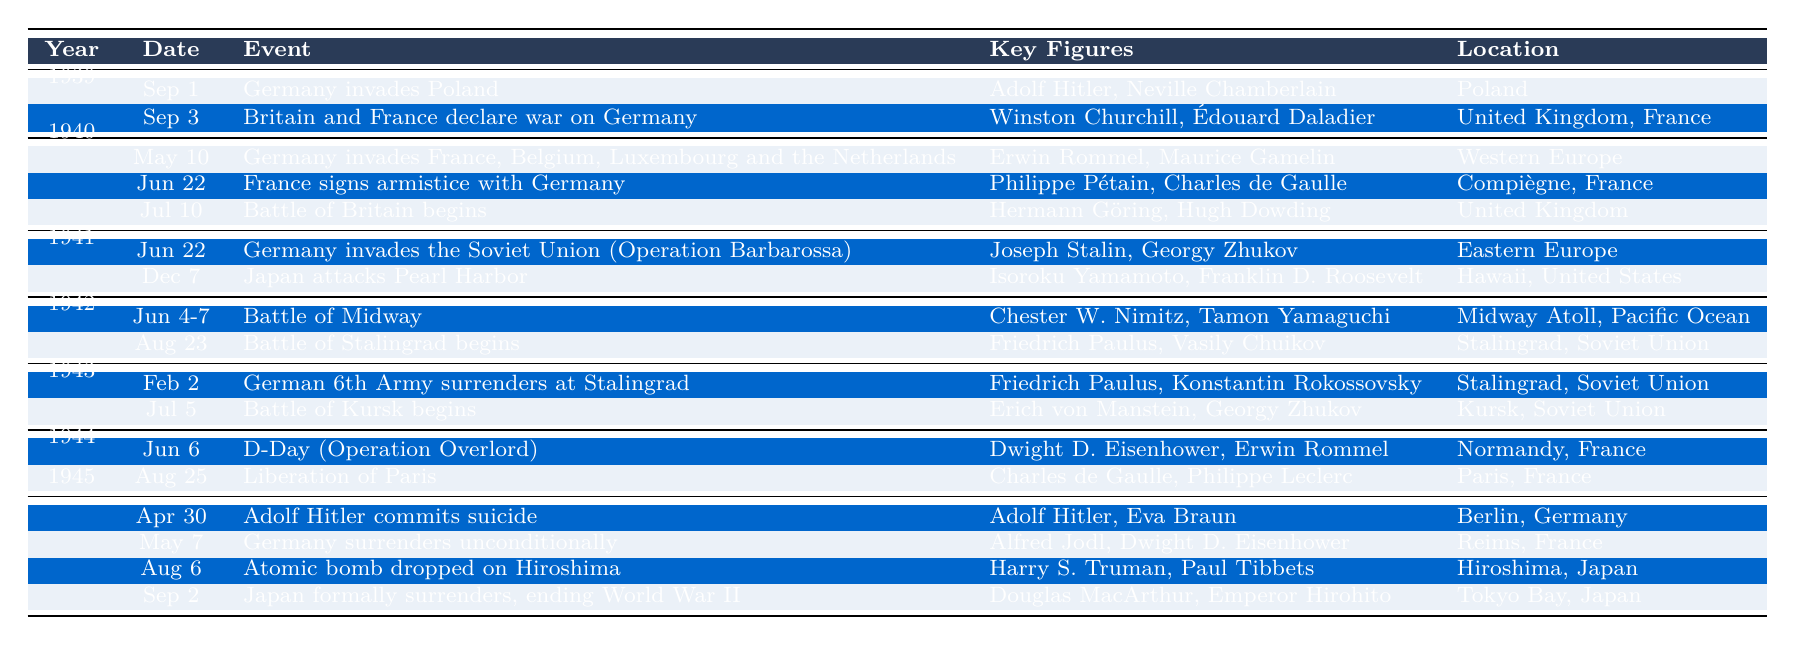What significant event occurred on September 1, 1939? According to the table, on September 1, 1939, Germany invaded Poland, marking the start of World War II.
Answer: Germany invades Poland Who were the key figures involved in the Battle of Midway in June 1942? The table indicates that Chester W. Nimitz and Tamon Yamaguchi were key figures in the Battle of Midway, which took place from June 4-7, 1942.
Answer: Chester W. Nimitz, Tamon Yamaguchi In what year did the Battle of Britain begin? According to the table, the Battle of Britain began on July 10, 1940, which allows us to identify the year as 1940.
Answer: 1940 How many events are listed for the year 1941? The table shows that there are two events listed for the year 1941: Germany's invasion of the Soviet Union and Japan's attack on Pearl Harbor.
Answer: 2 Which event occurred first, Germany signing an armistice with France or the Battle of Stalingrad beginning? Based on the table, France signed an armistice with Germany on June 22, 1940, while the Battle of Stalingrad began on August 23, 1942. Since June 1940 is before August 1942, the armistice occurred first.
Answer: Germany signs armistice with France Who were the key figures during Operation Overlord in June 1944? From the table, the key figures during D-Day (Operation Overlord) on June 6, 1944, were Dwight D. Eisenhower and Erwin Rommel.
Answer: Dwight D. Eisenhower, Erwin Rommel Was the Japanese attack on Pearl Harbor prior to or after Germany's invasion of the Soviet Union? The table indicates Japan attacked Pearl Harbor on December 7, 1941, and Germany invaded the Soviet Union (Operation Barbarossa) on June 22, 1941. Since June 1941 is prior to December 1941, the attack on Pearl Harbor occurred after Germany's invasion.
Answer: After What is the difference in days between the date of Adolf Hitler's suicide and the date of Japan's formal surrender? According to the table, Adolf Hitler committed suicide on April 30, 1945, and Japan formally surrendered on September 2, 1945. The difference is 124 days (from April 30 to September 2).
Answer: 124 days Identify the year in which Germany unconditionally surrendered, and describe the event that occurred on that date. Looking at the table, Germany unconditionally surrendered on May 7, 1945, which was an event marking the end of hostilities in Europe.
Answer: 1945, Germany surrenders unconditionally Which battles were fought in the Soviet Union according to the provided events? As indicated in the table, the events fought in the Soviet Union are the Battle of Stalingrad beginning in August 1942 and the German 6th Army surrendering at Stalingrad in February 1943.
Answer: Battle of Stalingrad In which month did the liberation of Paris occur? The table states that the liberation of Paris occurred on August 25, 1944, making it clear that the month is August.
Answer: August 